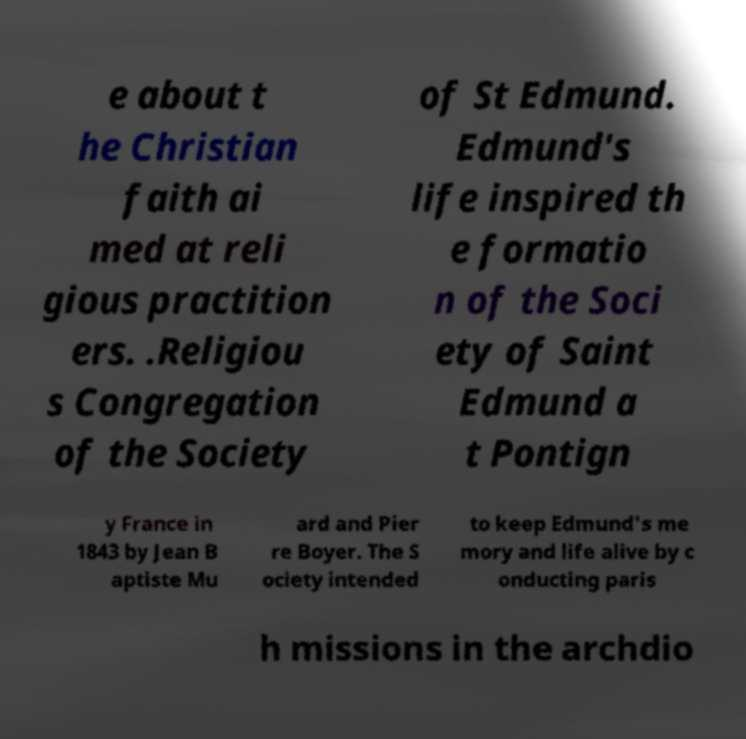Could you assist in decoding the text presented in this image and type it out clearly? e about t he Christian faith ai med at reli gious practition ers. .Religiou s Congregation of the Society of St Edmund. Edmund's life inspired th e formatio n of the Soci ety of Saint Edmund a t Pontign y France in 1843 by Jean B aptiste Mu ard and Pier re Boyer. The S ociety intended to keep Edmund's me mory and life alive by c onducting paris h missions in the archdio 